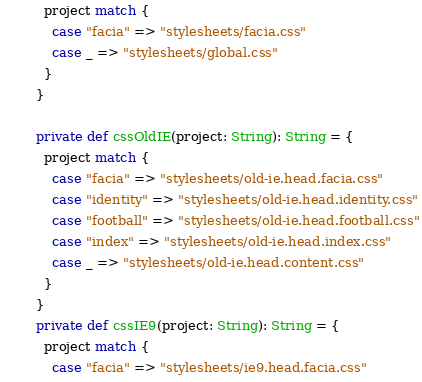<code> <loc_0><loc_0><loc_500><loc_500><_Scala_>      project match {
        case "facia" => "stylesheets/facia.css"
        case _ => "stylesheets/global.css"
      }
    }

    private def cssOldIE(project: String): String = {
      project match {
        case "facia" => "stylesheets/old-ie.head.facia.css"
        case "identity" => "stylesheets/old-ie.head.identity.css"
        case "football" => "stylesheets/old-ie.head.football.css"
        case "index" => "stylesheets/old-ie.head.index.css"
        case _ => "stylesheets/old-ie.head.content.css"
      }
    }
    private def cssIE9(project: String): String = {
      project match {
        case "facia" => "stylesheets/ie9.head.facia.css"</code> 